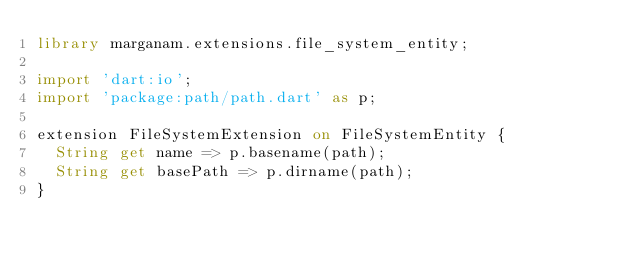<code> <loc_0><loc_0><loc_500><loc_500><_Dart_>library marganam.extensions.file_system_entity;

import 'dart:io';
import 'package:path/path.dart' as p;

extension FileSystemExtension on FileSystemEntity {
  String get name => p.basename(path);
  String get basePath => p.dirname(path);
}
</code> 